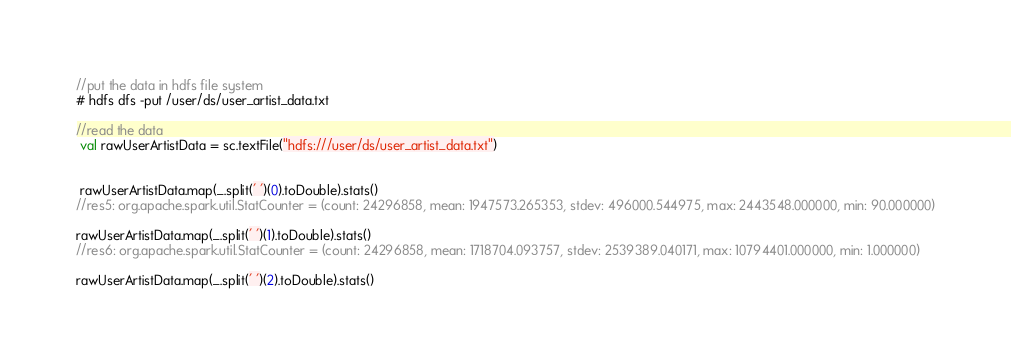Convert code to text. <code><loc_0><loc_0><loc_500><loc_500><_Scala_>//put the data in hdfs file system
# hdfs dfs -put /user/ds/user_artist_data.txt

//read the data
 val rawUserArtistData = sc.textFile("hdfs:///user/ds/user_artist_data.txt")


 rawUserArtistData.map(_.split(' ')(0).toDouble).stats()
//res5: org.apache.spark.util.StatCounter = (count: 24296858, mean: 1947573.265353, stdev: 496000.544975, max: 2443548.000000, min: 90.000000)

rawUserArtistData.map(_.split(' ')(1).toDouble).stats()
//res6: org.apache.spark.util.StatCounter = (count: 24296858, mean: 1718704.093757, stdev: 2539389.040171, max: 10794401.000000, min: 1.000000)

rawUserArtistData.map(_.split(' ')(2).toDouble).stats()</code> 